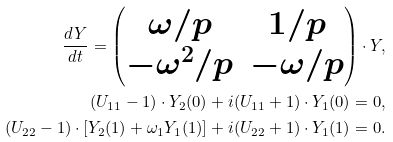<formula> <loc_0><loc_0><loc_500><loc_500>\frac { d Y } { d t } = \begin{pmatrix} \omega / p & 1 / p \\ - \omega ^ { 2 } / p & - \omega / p \end{pmatrix} \cdot Y , \\ ( U _ { 1 1 } - 1 ) \cdot Y _ { 2 } ( 0 ) + i ( U _ { 1 1 } + 1 ) \cdot Y _ { 1 } ( 0 ) = 0 , \\ ( U _ { 2 2 } - 1 ) \cdot [ Y _ { 2 } ( 1 ) + \omega _ { 1 } Y _ { 1 } ( 1 ) ] + i ( U _ { 2 2 } + 1 ) \cdot Y _ { 1 } ( 1 ) = 0 .</formula> 